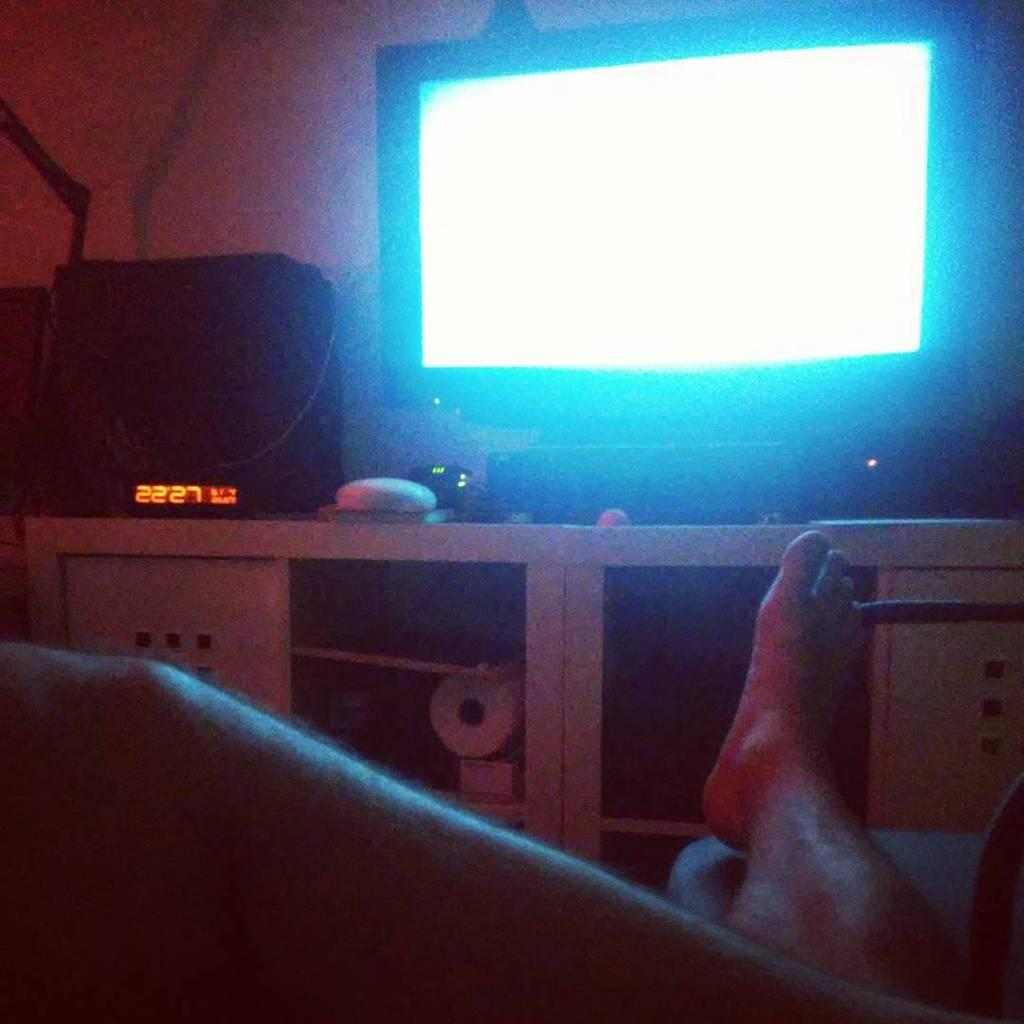<image>
Offer a succinct explanation of the picture presented. A man watching TV and there is a digital clock reading 22:27. 